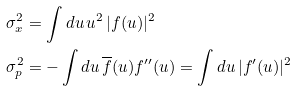Convert formula to latex. <formula><loc_0><loc_0><loc_500><loc_500>\sigma _ { x } ^ { 2 } & = \int d u \, u ^ { 2 } \, | f ( u ) | ^ { 2 } \\ \sigma _ { p } ^ { 2 } & = - \int d u \, \overline { f } ( u ) f ^ { \prime \prime } ( u ) = \int d u \, | f ^ { \prime } ( u ) | ^ { 2 }</formula> 